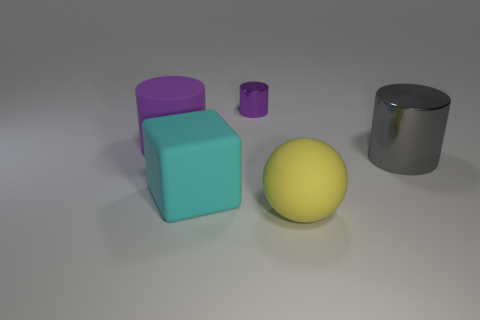How big is the cylinder that is in front of the purple metal cylinder and on the left side of the rubber sphere?
Make the answer very short. Large. What is the shape of the yellow rubber object?
Offer a very short reply. Sphere. Are there any other things that have the same size as the purple metal thing?
Keep it short and to the point. No. Is the number of small purple metal objects that are behind the big gray shiny cylinder greater than the number of big green things?
Provide a short and direct response. Yes. There is a big matte thing that is behind the large cylinder that is in front of the purple cylinder that is in front of the tiny shiny cylinder; what is its shape?
Offer a very short reply. Cylinder. Does the cylinder on the right side of the yellow rubber ball have the same size as the big purple object?
Make the answer very short. Yes. What is the shape of the thing that is right of the small thing and behind the yellow matte object?
Provide a short and direct response. Cylinder. There is a tiny cylinder; is it the same color as the large cylinder to the left of the large gray shiny thing?
Your answer should be very brief. Yes. The large cylinder to the left of the metallic cylinder that is behind the big cylinder right of the yellow matte ball is what color?
Offer a terse response. Purple. What color is the big metal thing that is the same shape as the small purple thing?
Your response must be concise. Gray. 